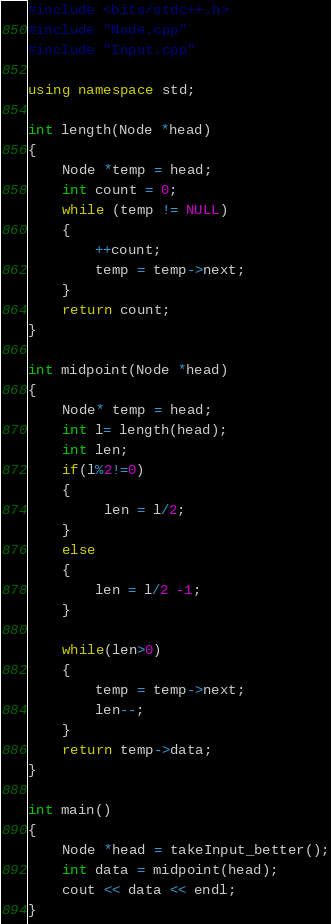Convert code to text. <code><loc_0><loc_0><loc_500><loc_500><_C++_>#include <bits/stdc++.h>
#include "Node.cpp"
#include "Input.cpp"

using namespace std;

int length(Node *head)
{
    Node *temp = head;
    int count = 0;
    while (temp != NULL)
    {
        ++count;
        temp = temp->next;
    }
    return count;
}

int midpoint(Node *head)
{
    Node* temp = head;
    int l= length(head);
    int len;
    if(l%2!=0)
    {
         len = l/2;
    }
    else
    {
        len = l/2 -1;
    }

    while(len>0)
    {
        temp = temp->next;
        len--;
    }
    return temp->data;
}

int main()
{
    Node *head = takeInput_better();
    int data = midpoint(head);
    cout << data << endl;
}
</code> 